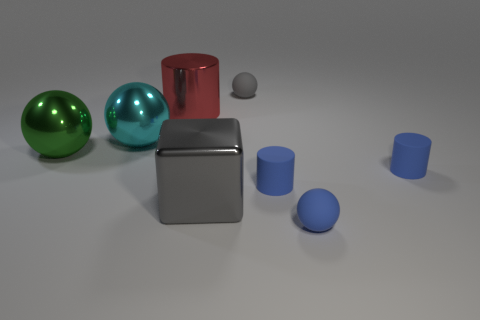Subtract all blue blocks. How many blue cylinders are left? 2 Subtract all gray matte spheres. How many spheres are left? 3 Subtract 1 cylinders. How many cylinders are left? 2 Subtract all green balls. How many balls are left? 3 Add 1 gray metallic blocks. How many objects exist? 9 Subtract all cyan spheres. Subtract all purple cubes. How many spheres are left? 3 Add 3 cyan matte things. How many cyan matte things exist? 3 Subtract 0 red balls. How many objects are left? 8 Subtract all cylinders. How many objects are left? 5 Subtract all metallic blocks. Subtract all large purple matte cubes. How many objects are left? 7 